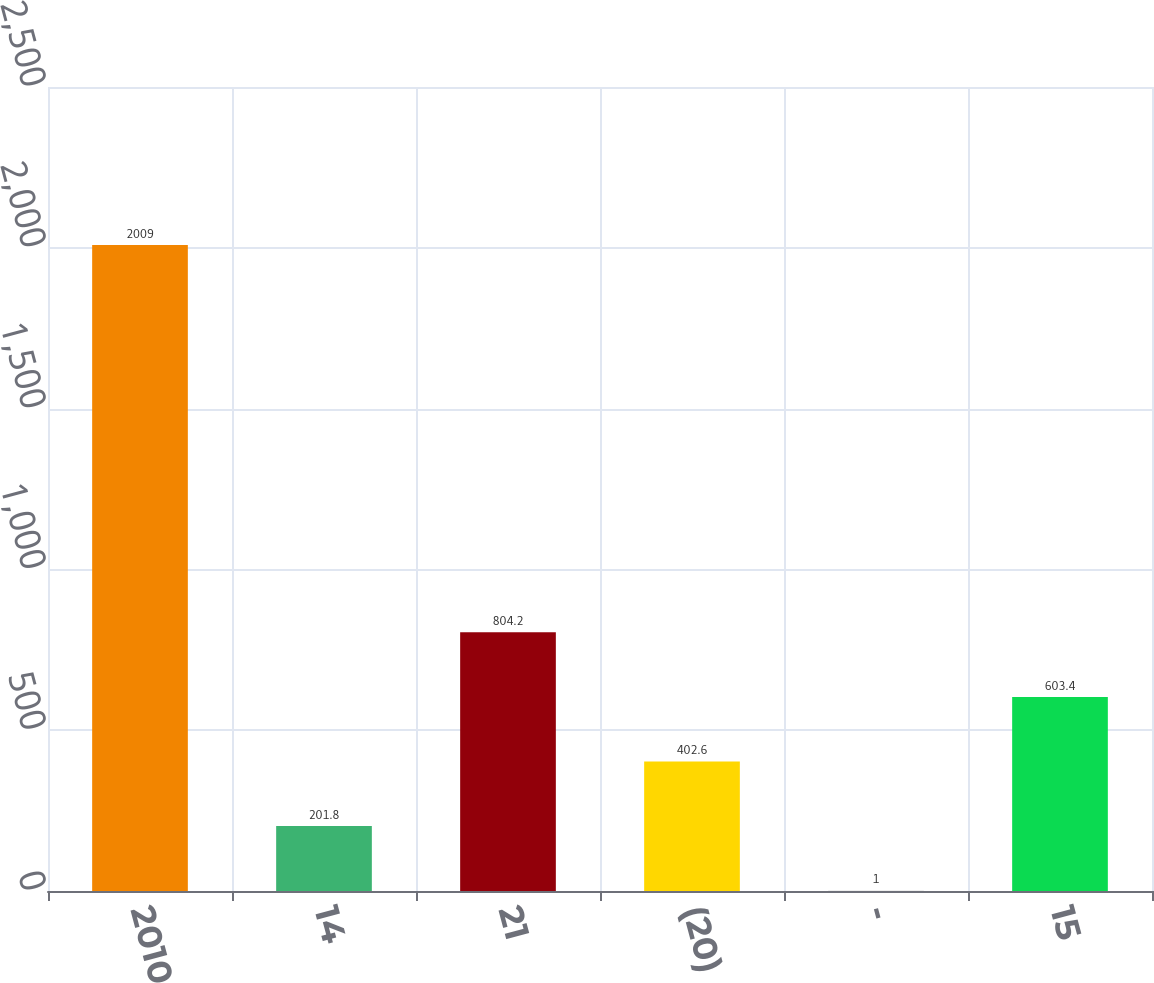Convert chart. <chart><loc_0><loc_0><loc_500><loc_500><bar_chart><fcel>2010<fcel>14<fcel>21<fcel>(20)<fcel>-<fcel>15<nl><fcel>2009<fcel>201.8<fcel>804.2<fcel>402.6<fcel>1<fcel>603.4<nl></chart> 